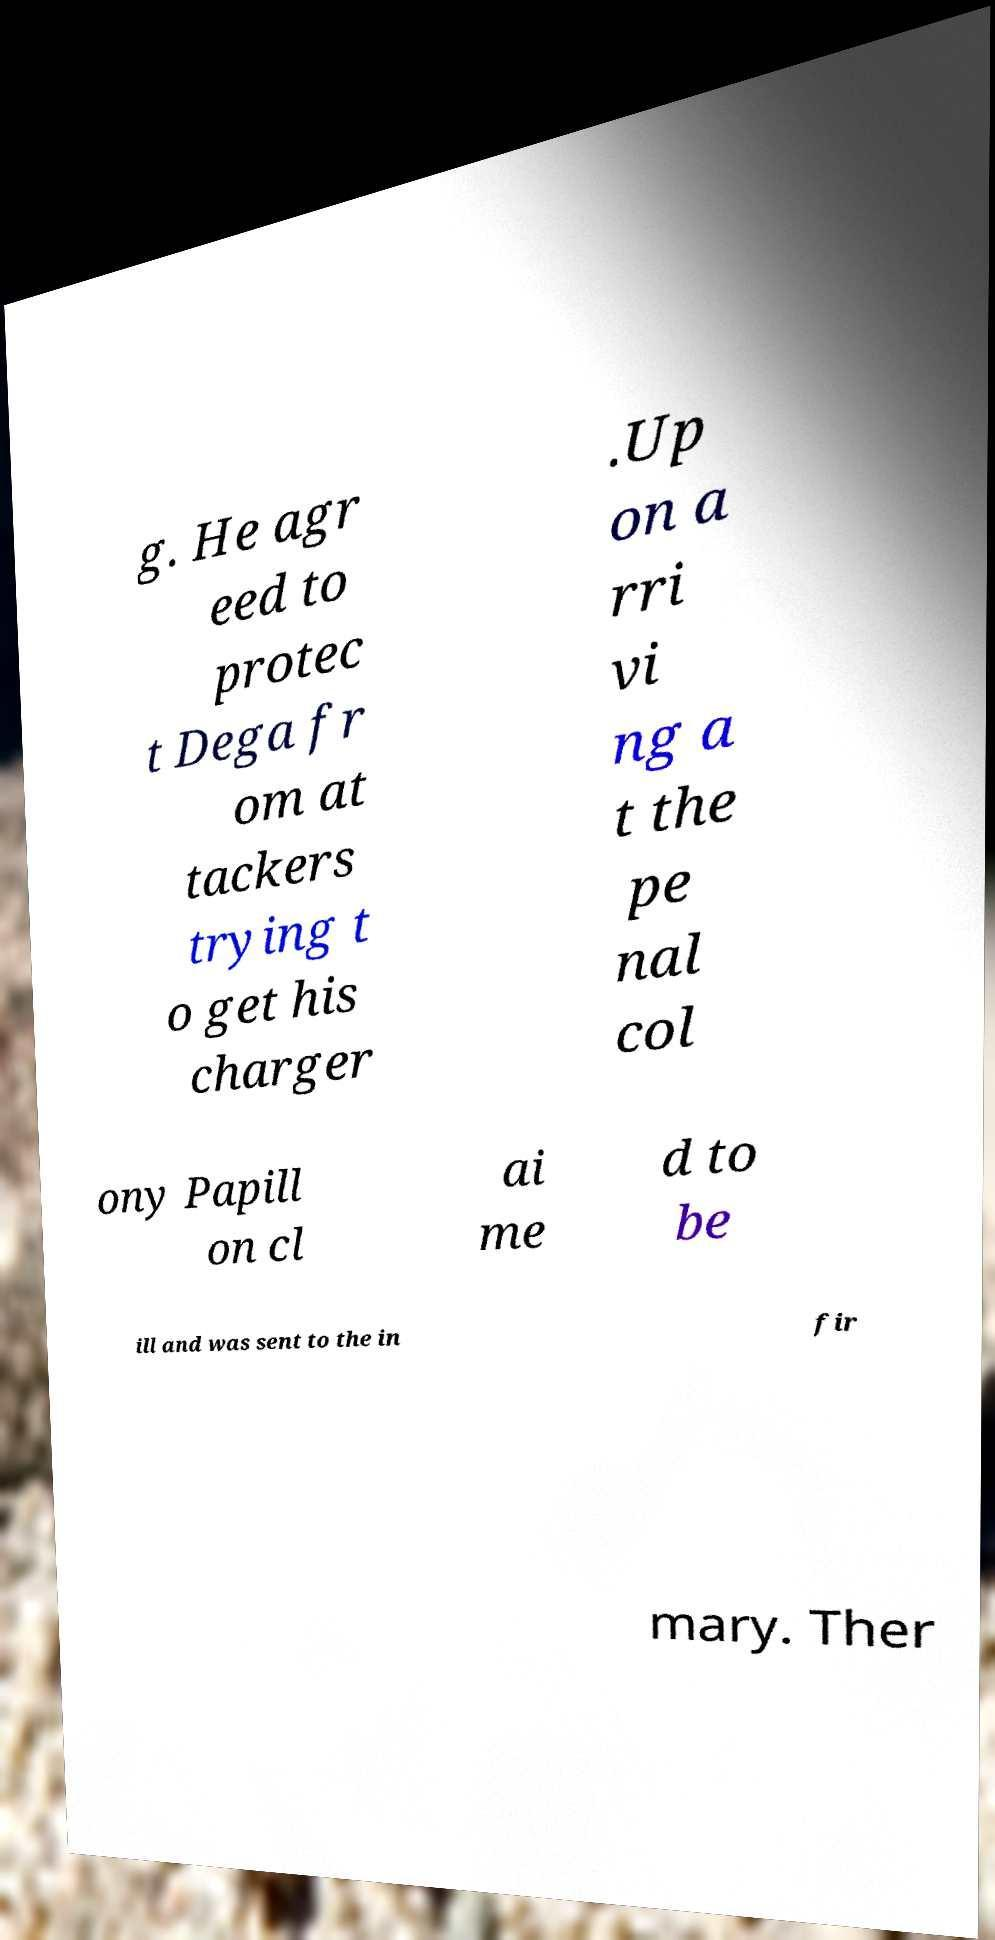I need the written content from this picture converted into text. Can you do that? g. He agr eed to protec t Dega fr om at tackers trying t o get his charger .Up on a rri vi ng a t the pe nal col ony Papill on cl ai me d to be ill and was sent to the in fir mary. Ther 